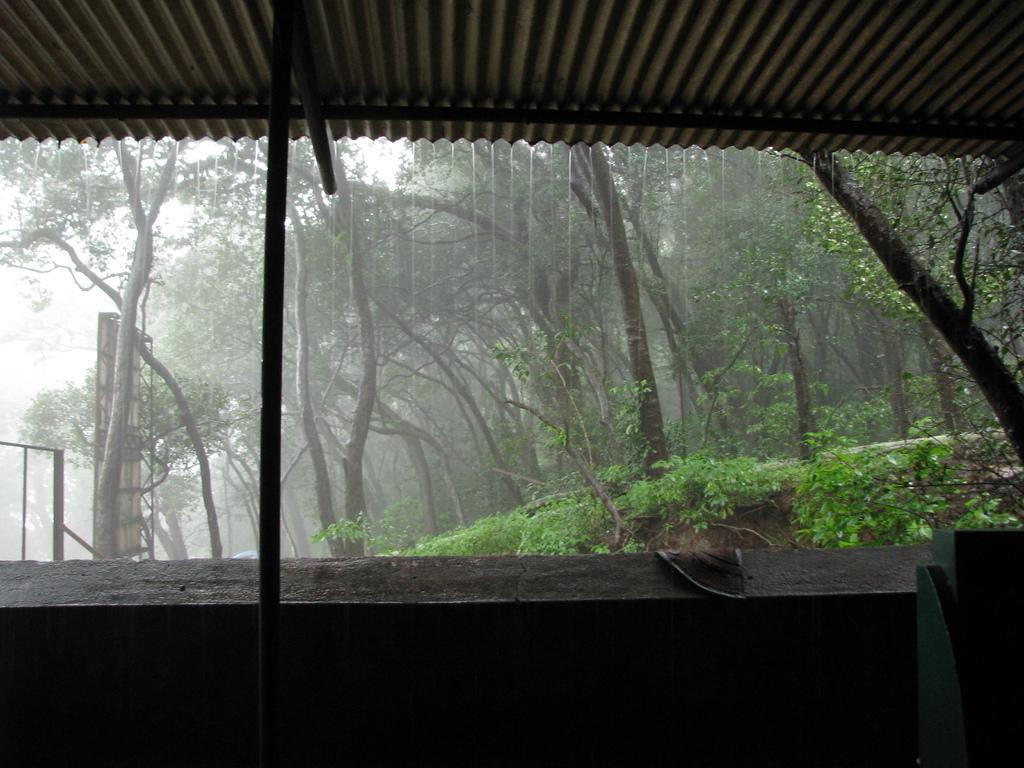Please provide a concise description of this image. In this image there is a shed, few trees, plants and poles under the rain. 